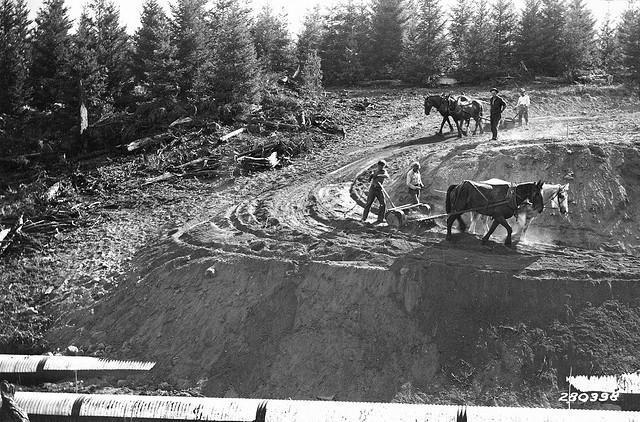How many animals are there?
Give a very brief answer. 4. 